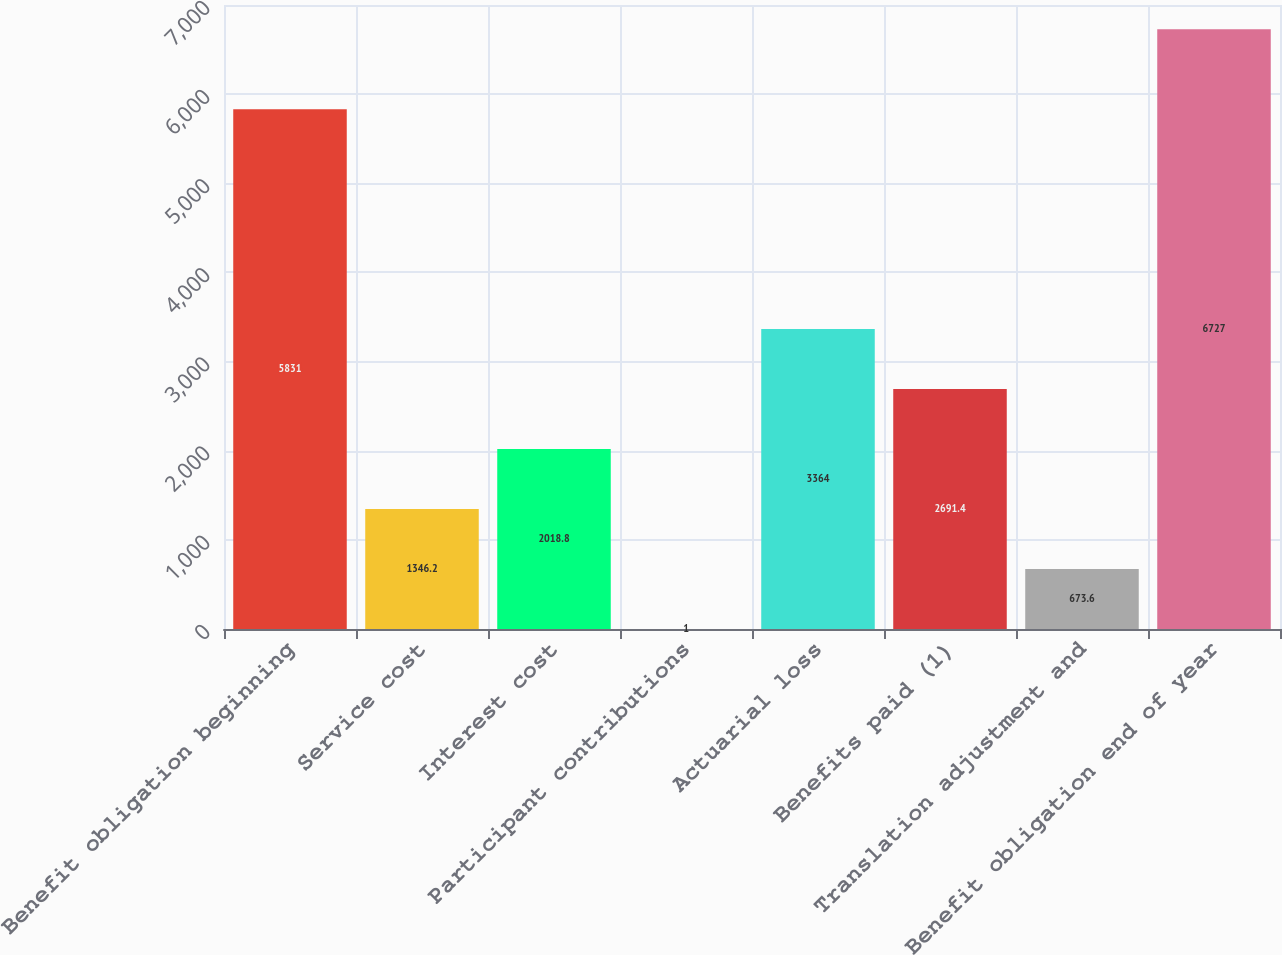<chart> <loc_0><loc_0><loc_500><loc_500><bar_chart><fcel>Benefit obligation beginning<fcel>Service cost<fcel>Interest cost<fcel>Participant contributions<fcel>Actuarial loss<fcel>Benefits paid (1)<fcel>Translation adjustment and<fcel>Benefit obligation end of year<nl><fcel>5831<fcel>1346.2<fcel>2018.8<fcel>1<fcel>3364<fcel>2691.4<fcel>673.6<fcel>6727<nl></chart> 